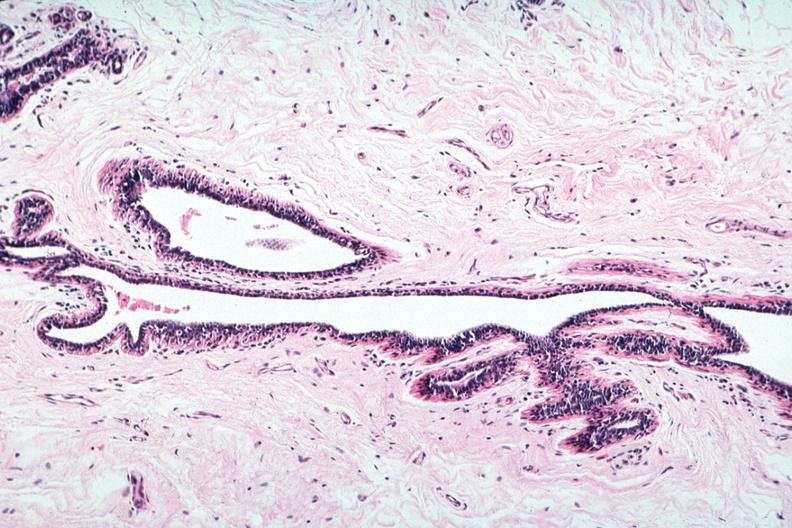where is this area in the body?
Answer the question using a single word or phrase. Breast 